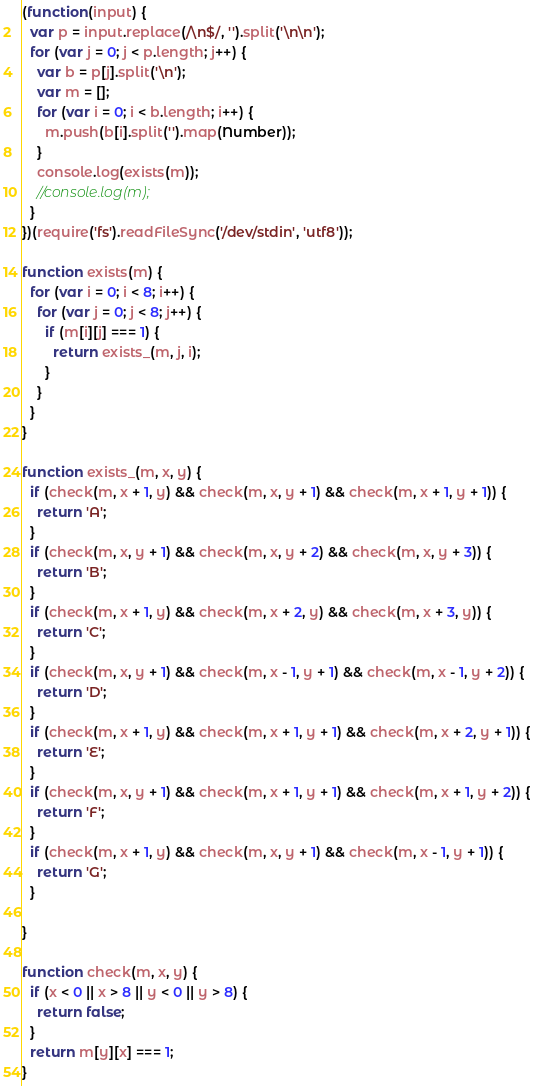<code> <loc_0><loc_0><loc_500><loc_500><_JavaScript_>(function(input) {
  var p = input.replace(/\n$/, '').split('\n\n');
  for (var j = 0; j < p.length; j++) {
    var b = p[j].split('\n');
    var m = [];
    for (var i = 0; i < b.length; i++) {
      m.push(b[i].split('').map(Number));
    }
    console.log(exists(m));
    //console.log(m);
  }
})(require('fs').readFileSync('/dev/stdin', 'utf8'));

function exists(m) {
  for (var i = 0; i < 8; i++) {
    for (var j = 0; j < 8; j++) {
      if (m[i][j] === 1) {
        return exists_(m, j, i);
      }
    }
  }
}

function exists_(m, x, y) {
  if (check(m, x + 1, y) && check(m, x, y + 1) && check(m, x + 1, y + 1)) {
    return 'A';
  }
  if (check(m, x, y + 1) && check(m, x, y + 2) && check(m, x, y + 3)) {
    return 'B';
  }
  if (check(m, x + 1, y) && check(m, x + 2, y) && check(m, x + 3, y)) {
    return 'C';
  }
  if (check(m, x, y + 1) && check(m, x - 1, y + 1) && check(m, x - 1, y + 2)) {
    return 'D';
  }
  if (check(m, x + 1, y) && check(m, x + 1, y + 1) && check(m, x + 2, y + 1)) {
    return 'E';
  }
  if (check(m, x, y + 1) && check(m, x + 1, y + 1) && check(m, x + 1, y + 2)) {
    return 'F';
  }
  if (check(m, x + 1, y) && check(m, x, y + 1) && check(m, x - 1, y + 1)) {
    return 'G';
  }

}

function check(m, x, y) {
  if (x < 0 || x > 8 || y < 0 || y > 8) {
    return false;
  }
  return m[y][x] === 1;
}</code> 